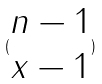<formula> <loc_0><loc_0><loc_500><loc_500>( \begin{matrix} n - 1 \\ x - 1 \end{matrix} )</formula> 